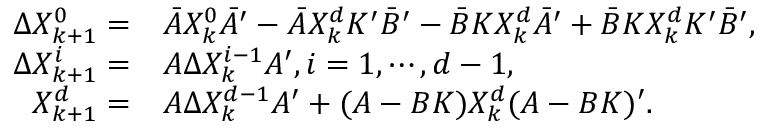Convert formula to latex. <formula><loc_0><loc_0><loc_500><loc_500>\begin{array} { r l } { \Delta X _ { k + 1 } ^ { 0 } = } & { \bar { A } X _ { k } ^ { 0 } \bar { A } ^ { \prime } - \bar { A } X _ { k } ^ { d } K ^ { \prime } \bar { B } ^ { \prime } - \bar { B } K { X } _ { k } ^ { d } \bar { A } ^ { \prime } + \bar { B } K { X } _ { k } ^ { d } K ^ { \prime } \bar { B } ^ { \prime } , } \\ { \Delta X _ { k + 1 } ^ { i } = } & { A \Delta X _ { k } ^ { i - 1 } A ^ { \prime } , i = 1 , \cdots , d - 1 , } \\ { X _ { k + 1 } ^ { d } = } & { A \Delta X _ { k } ^ { d - 1 } A ^ { \prime } + ( A - B K ) X _ { k } ^ { d } ( A - B K ) ^ { \prime } . } \end{array}</formula> 